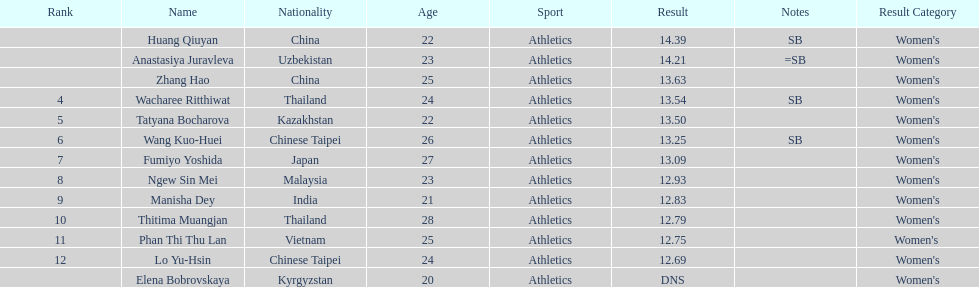Which country came in first? China. 